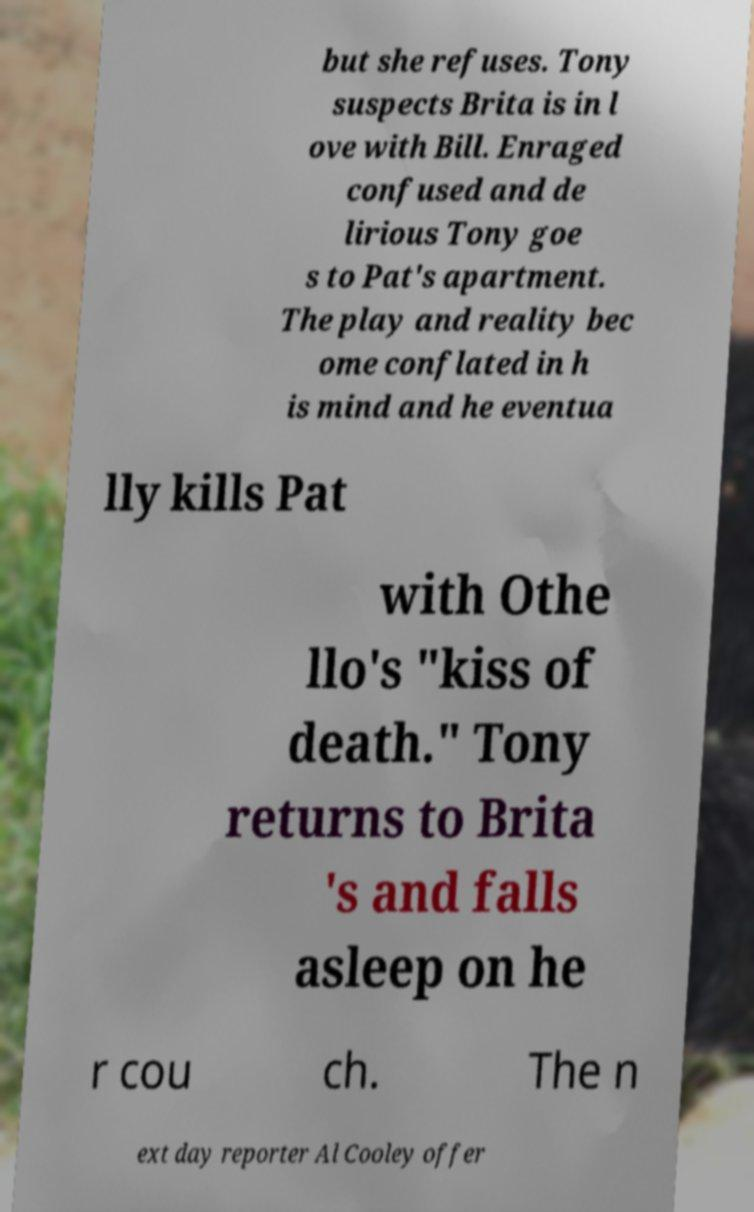For documentation purposes, I need the text within this image transcribed. Could you provide that? but she refuses. Tony suspects Brita is in l ove with Bill. Enraged confused and de lirious Tony goe s to Pat's apartment. The play and reality bec ome conflated in h is mind and he eventua lly kills Pat with Othe llo's "kiss of death." Tony returns to Brita 's and falls asleep on he r cou ch. The n ext day reporter Al Cooley offer 